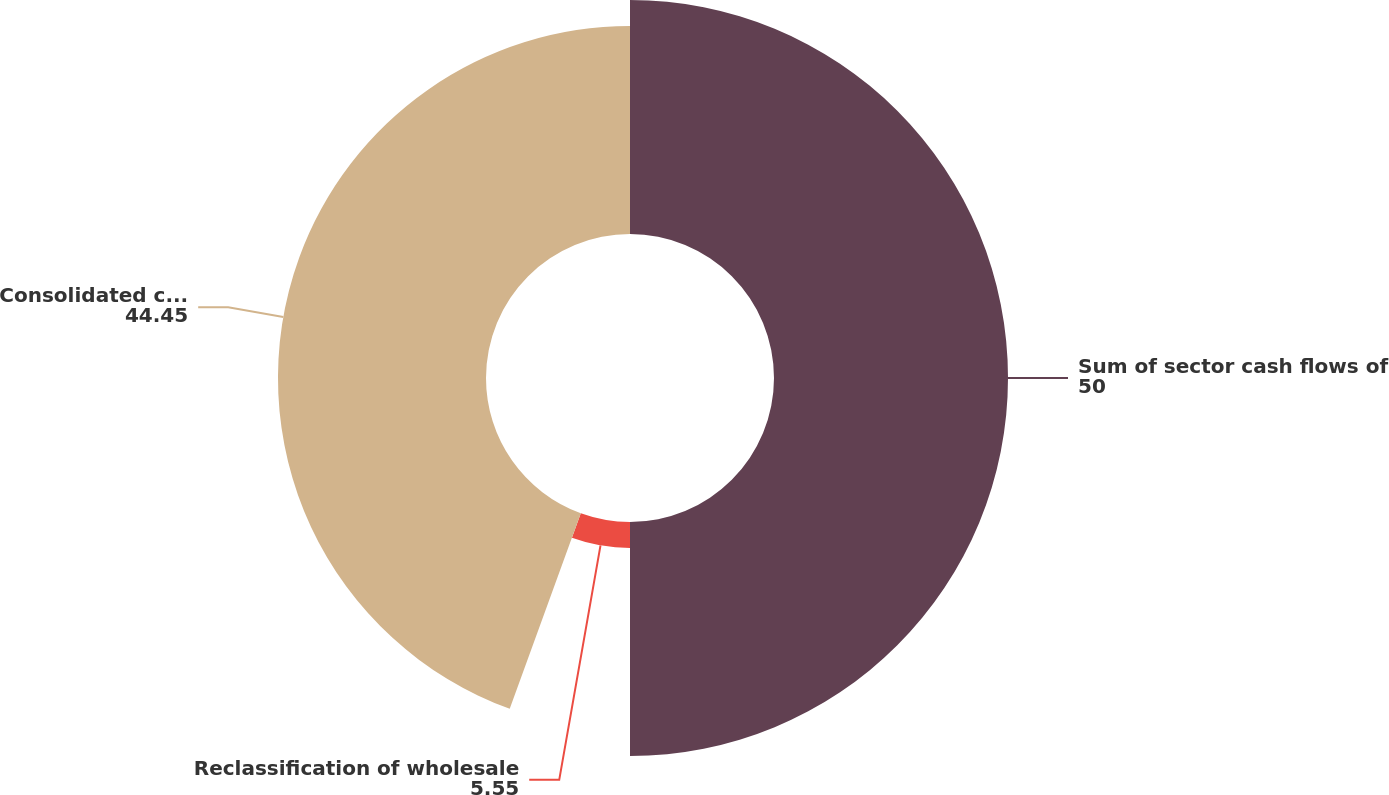Convert chart. <chart><loc_0><loc_0><loc_500><loc_500><pie_chart><fcel>Sum of sector cash flows of<fcel>Reclassification of wholesale<fcel>Consolidated cash flows of<nl><fcel>50.0%<fcel>5.55%<fcel>44.45%<nl></chart> 